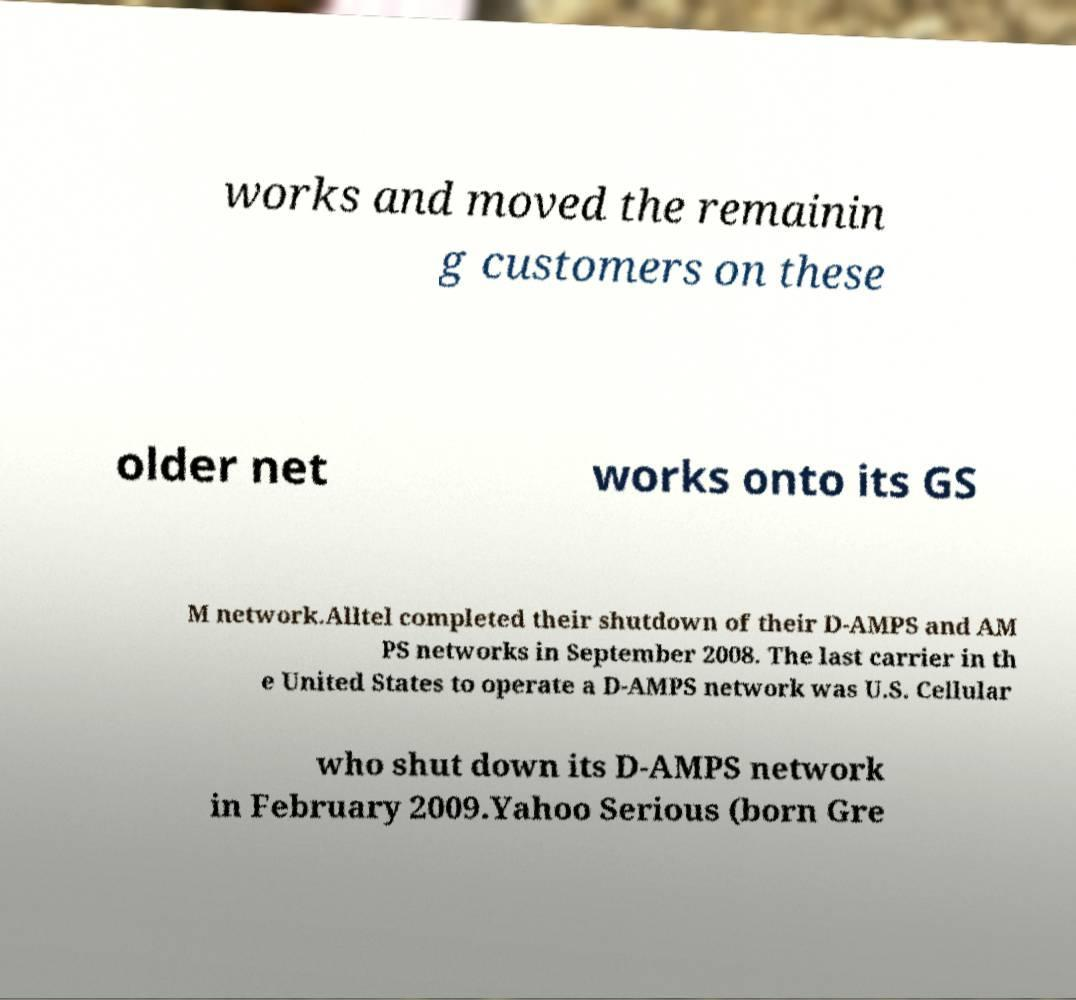Can you read and provide the text displayed in the image?This photo seems to have some interesting text. Can you extract and type it out for me? works and moved the remainin g customers on these older net works onto its GS M network.Alltel completed their shutdown of their D-AMPS and AM PS networks in September 2008. The last carrier in th e United States to operate a D-AMPS network was U.S. Cellular who shut down its D-AMPS network in February 2009.Yahoo Serious (born Gre 